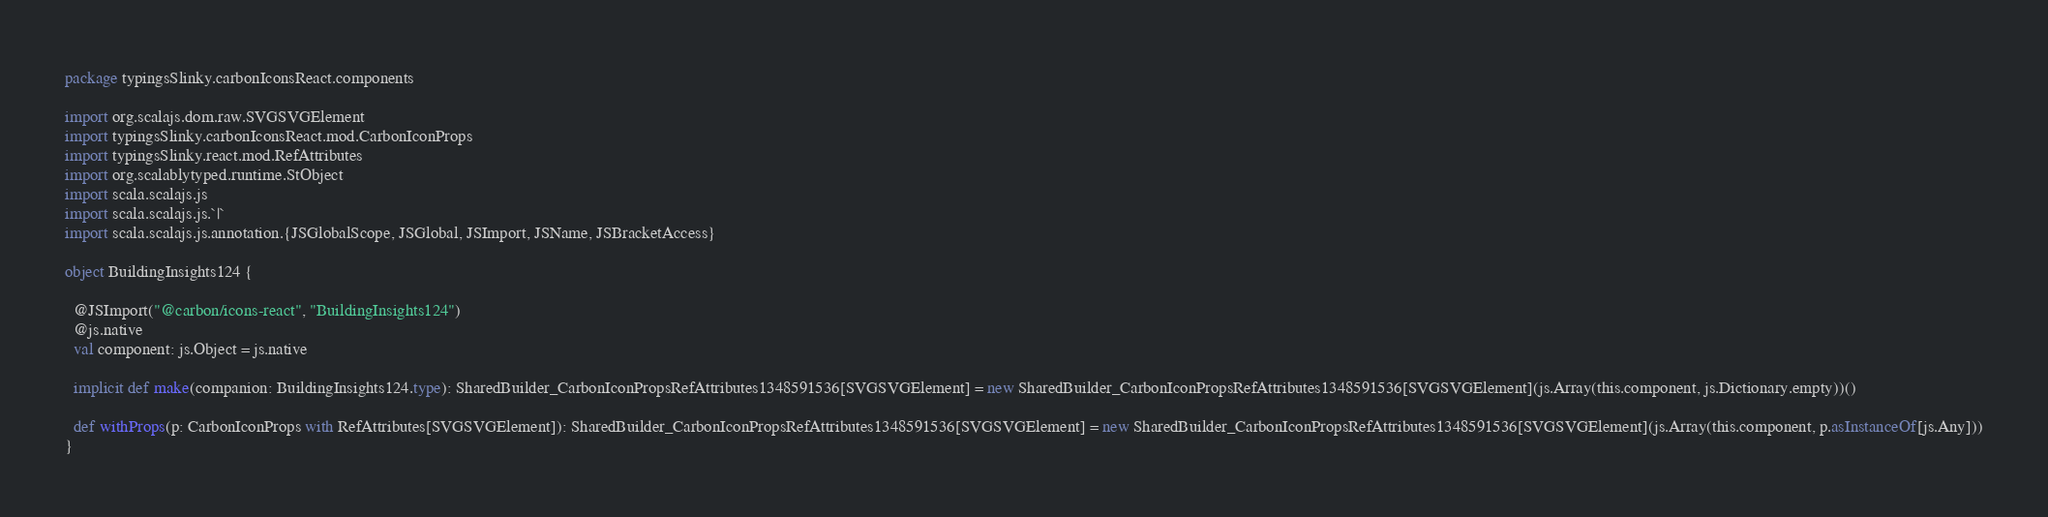<code> <loc_0><loc_0><loc_500><loc_500><_Scala_>package typingsSlinky.carbonIconsReact.components

import org.scalajs.dom.raw.SVGSVGElement
import typingsSlinky.carbonIconsReact.mod.CarbonIconProps
import typingsSlinky.react.mod.RefAttributes
import org.scalablytyped.runtime.StObject
import scala.scalajs.js
import scala.scalajs.js.`|`
import scala.scalajs.js.annotation.{JSGlobalScope, JSGlobal, JSImport, JSName, JSBracketAccess}

object BuildingInsights124 {
  
  @JSImport("@carbon/icons-react", "BuildingInsights124")
  @js.native
  val component: js.Object = js.native
  
  implicit def make(companion: BuildingInsights124.type): SharedBuilder_CarbonIconPropsRefAttributes1348591536[SVGSVGElement] = new SharedBuilder_CarbonIconPropsRefAttributes1348591536[SVGSVGElement](js.Array(this.component, js.Dictionary.empty))()
  
  def withProps(p: CarbonIconProps with RefAttributes[SVGSVGElement]): SharedBuilder_CarbonIconPropsRefAttributes1348591536[SVGSVGElement] = new SharedBuilder_CarbonIconPropsRefAttributes1348591536[SVGSVGElement](js.Array(this.component, p.asInstanceOf[js.Any]))
}
</code> 